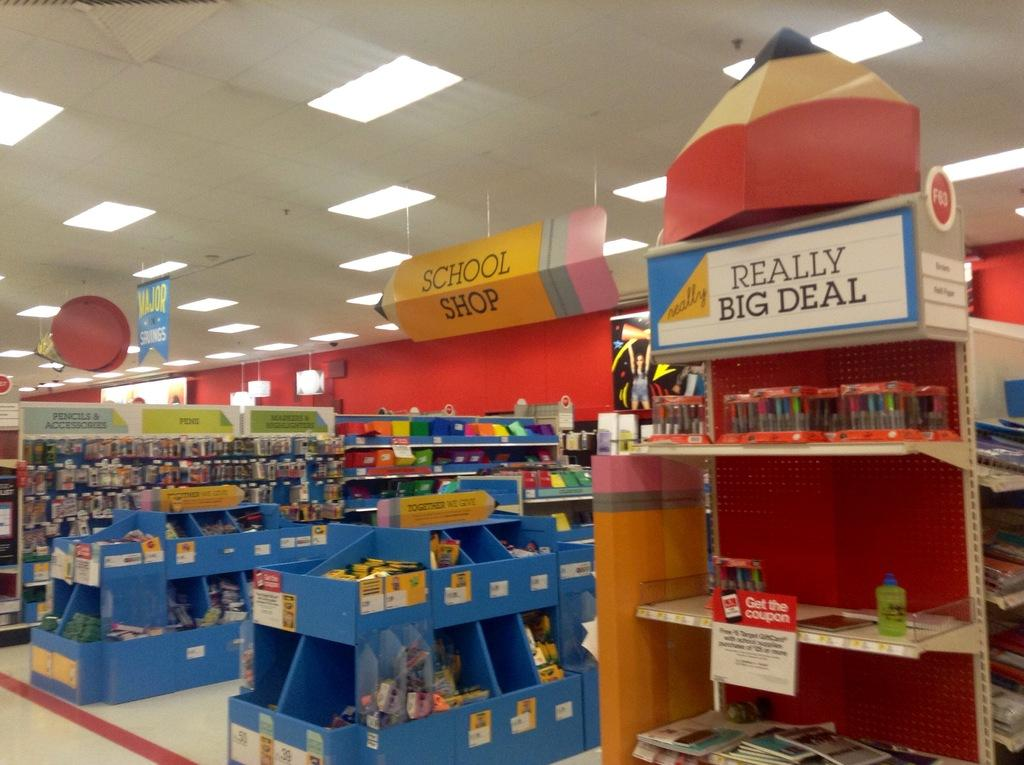<image>
Render a clear and concise summary of the photo. the school shop section of a big store with a stand reading really big deal at the top. 